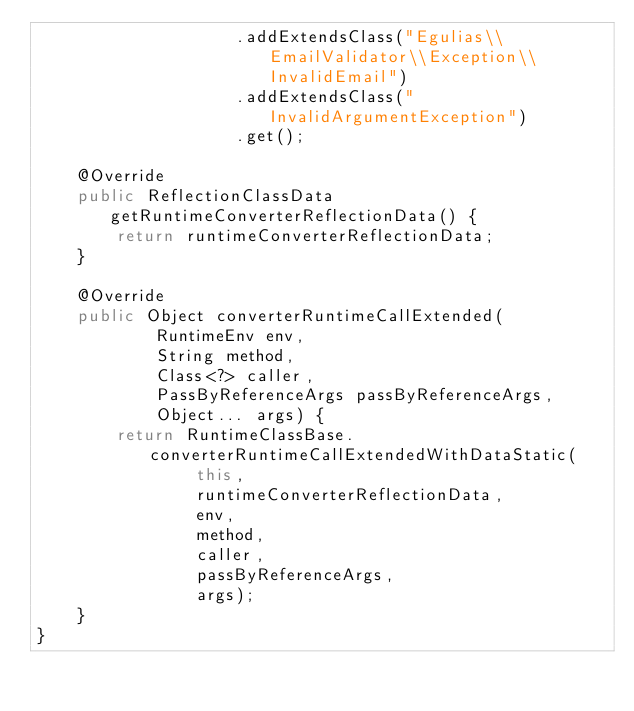<code> <loc_0><loc_0><loc_500><loc_500><_Java_>                    .addExtendsClass("Egulias\\EmailValidator\\Exception\\InvalidEmail")
                    .addExtendsClass("InvalidArgumentException")
                    .get();

    @Override
    public ReflectionClassData getRuntimeConverterReflectionData() {
        return runtimeConverterReflectionData;
    }

    @Override
    public Object converterRuntimeCallExtended(
            RuntimeEnv env,
            String method,
            Class<?> caller,
            PassByReferenceArgs passByReferenceArgs,
            Object... args) {
        return RuntimeClassBase.converterRuntimeCallExtendedWithDataStatic(
                this,
                runtimeConverterReflectionData,
                env,
                method,
                caller,
                passByReferenceArgs,
                args);
    }
}
</code> 